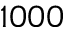<formula> <loc_0><loc_0><loc_500><loc_500>1 0 0 0</formula> 